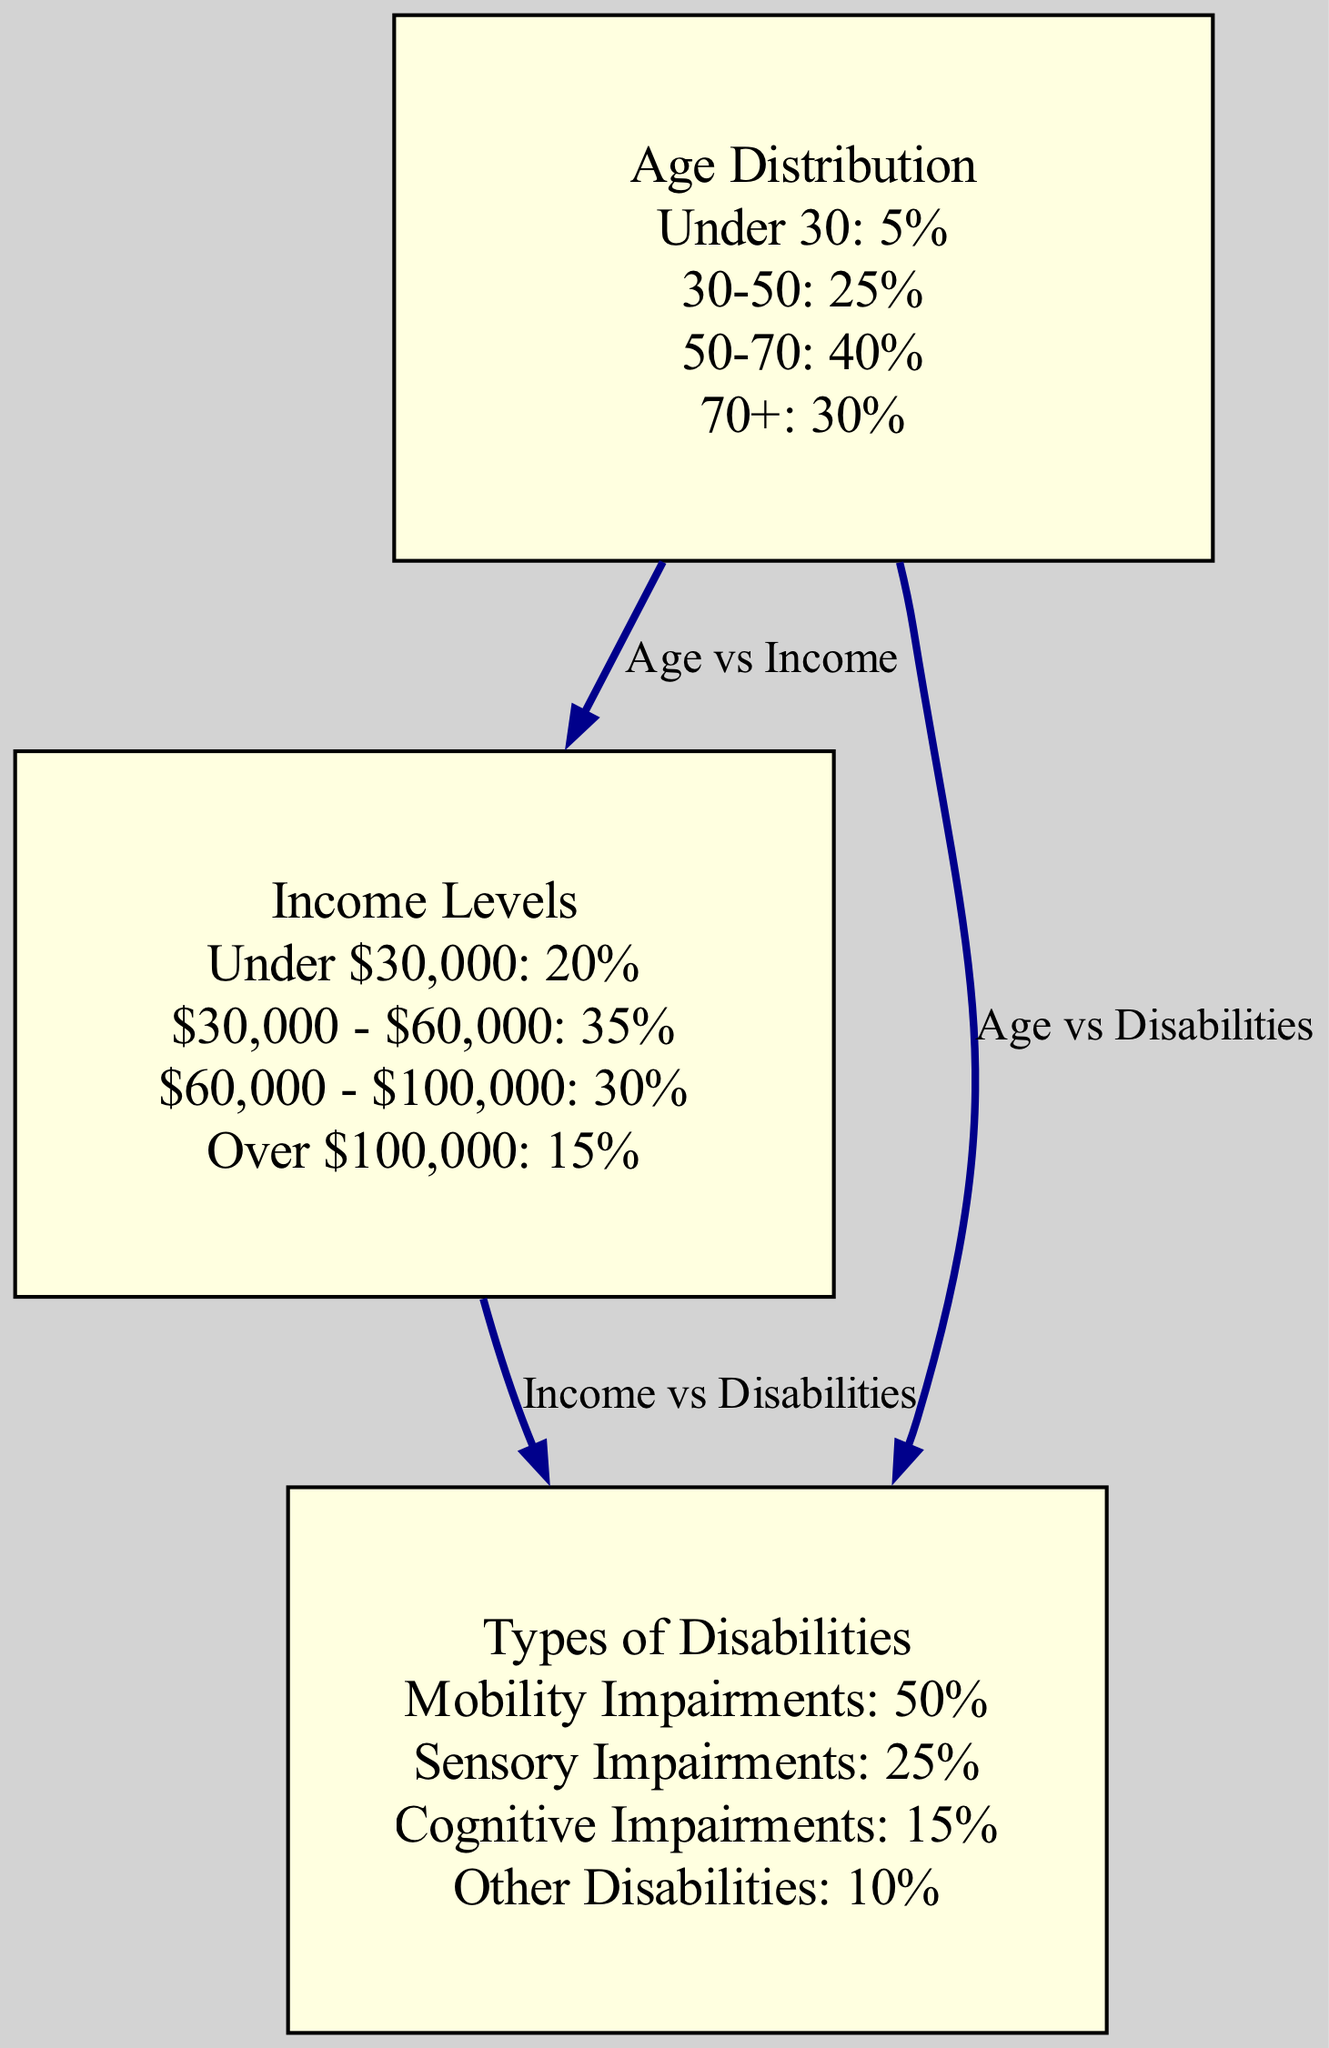What is the percentage of homeowners aged 30-50? The diagram indicates that the percentage of homeowners aged 30-50 is 25%. This information is found in the 'Age Distribution' node.
Answer: 25% What type of disability has the highest percentage? The diagram shows that 'Mobility Impairments' has the highest percentage at 50%, found in the 'Types of Disabilities' node.
Answer: Mobility Impairments How many total disabilities types are listed? The diagram lists four types of disabilities: Mobility Impairments, Sensory Impairments, Cognitive Impairments, and Other Disabilities. This information can be counted in the 'Types of Disabilities' node.
Answer: 4 What is the percentage of homeowners earning over $100,000? According to the 'Income Levels' node, the percentage of homeowners earning over $100,000 is 15%. This is clearly stated in that section of the diagram.
Answer: 15% Which age group has the lowest percentage? The 'Age Distribution' shows that the 'Under 30' age group has the lowest percentage at 5%. We can verify this by comparing the percentages of all age ranges listed.
Answer: Under 30 Is there a relationship between age and types of disabilities? The diagram indicates connectivity between 'Age Distribution' and 'Types of Disabilities' through an edge labeled "Age vs Disabilities," confirming that there is a relationship.
Answer: Yes What income range has the highest percentage? The 'Income Levels' node indicates that the '$30,000 - $60,000' range has the highest percentage at 35%. This information is explicitly stated under that category.
Answer: $30,000 - $60,000 What is the total percentage of homeowners with sensory impairments? According to the 'Types of Disabilities' node, sensory impairments account for 25% of the homeowners. This statistic is directly sourced from the node details.
Answer: 25% How are income and disabilities related according to this diagram? The diagram highlights a connection between 'Income Levels' and 'Types of Disabilities' through the edge labeled "Income vs Disabilities," showing that income levels may influence the type of disabilities homeowners have.
Answer: Yes 